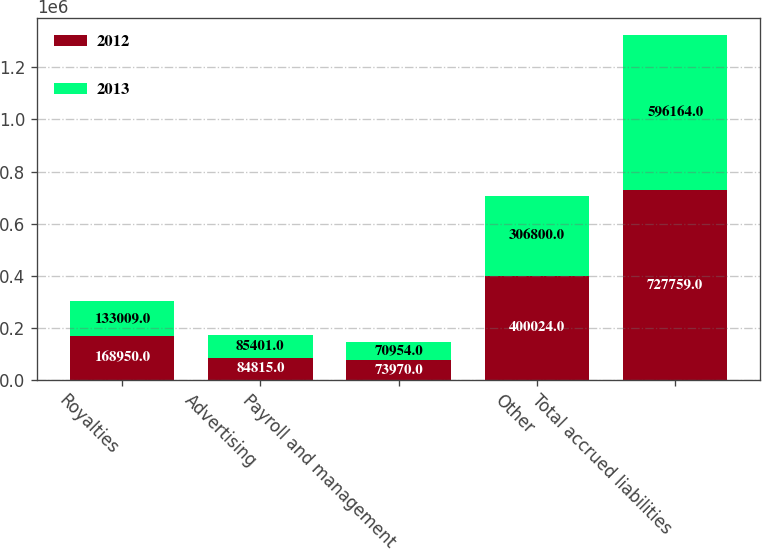Convert chart. <chart><loc_0><loc_0><loc_500><loc_500><stacked_bar_chart><ecel><fcel>Royalties<fcel>Advertising<fcel>Payroll and management<fcel>Other<fcel>Total accrued liabilities<nl><fcel>2012<fcel>168950<fcel>84815<fcel>73970<fcel>400024<fcel>727759<nl><fcel>2013<fcel>133009<fcel>85401<fcel>70954<fcel>306800<fcel>596164<nl></chart> 